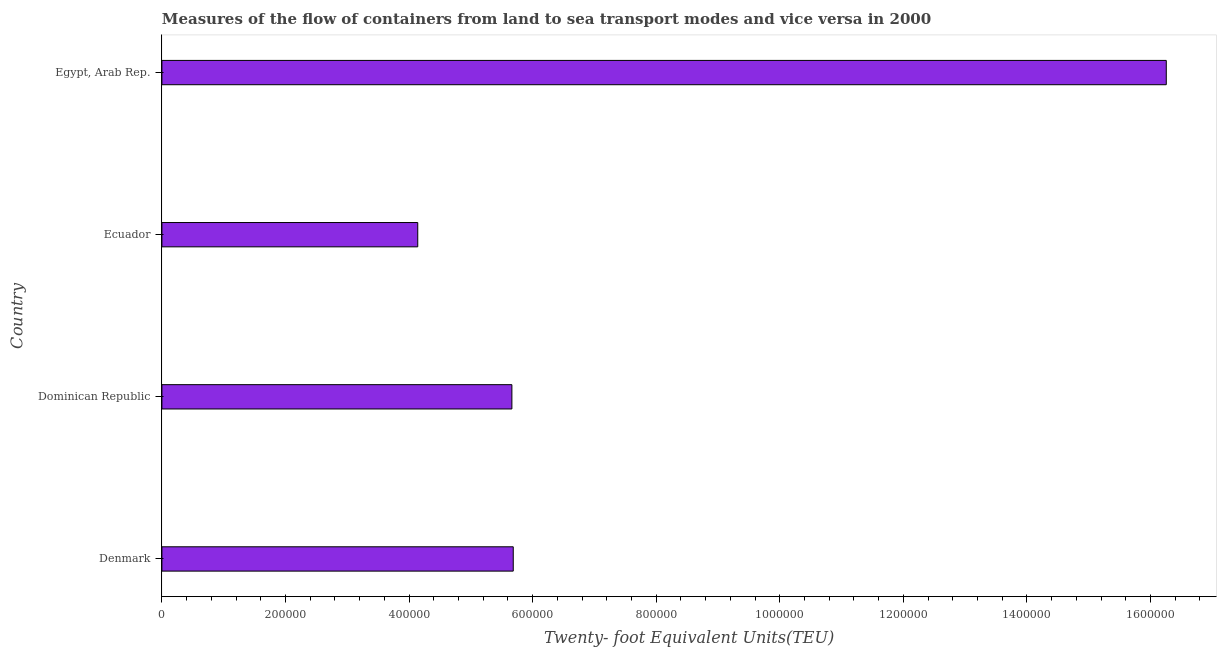Does the graph contain grids?
Make the answer very short. No. What is the title of the graph?
Provide a short and direct response. Measures of the flow of containers from land to sea transport modes and vice versa in 2000. What is the label or title of the X-axis?
Your response must be concise. Twenty- foot Equivalent Units(TEU). What is the container port traffic in Egypt, Arab Rep.?
Your answer should be compact. 1.63e+06. Across all countries, what is the maximum container port traffic?
Your response must be concise. 1.63e+06. Across all countries, what is the minimum container port traffic?
Ensure brevity in your answer.  4.14e+05. In which country was the container port traffic maximum?
Offer a very short reply. Egypt, Arab Rep. In which country was the container port traffic minimum?
Provide a short and direct response. Ecuador. What is the sum of the container port traffic?
Your answer should be compact. 3.17e+06. What is the difference between the container port traffic in Denmark and Egypt, Arab Rep.?
Ensure brevity in your answer.  -1.06e+06. What is the average container port traffic per country?
Your answer should be compact. 7.94e+05. What is the median container port traffic?
Your response must be concise. 5.68e+05. What is the ratio of the container port traffic in Denmark to that in Ecuador?
Make the answer very short. 1.37. What is the difference between the highest and the second highest container port traffic?
Give a very brief answer. 1.06e+06. What is the difference between the highest and the lowest container port traffic?
Offer a very short reply. 1.21e+06. In how many countries, is the container port traffic greater than the average container port traffic taken over all countries?
Offer a very short reply. 1. Are all the bars in the graph horizontal?
Keep it short and to the point. Yes. Are the values on the major ticks of X-axis written in scientific E-notation?
Your answer should be very brief. No. What is the Twenty- foot Equivalent Units(TEU) in Denmark?
Make the answer very short. 5.69e+05. What is the Twenty- foot Equivalent Units(TEU) in Dominican Republic?
Your answer should be very brief. 5.66e+05. What is the Twenty- foot Equivalent Units(TEU) of Ecuador?
Provide a short and direct response. 4.14e+05. What is the Twenty- foot Equivalent Units(TEU) in Egypt, Arab Rep.?
Offer a terse response. 1.63e+06. What is the difference between the Twenty- foot Equivalent Units(TEU) in Denmark and Dominican Republic?
Keep it short and to the point. 2181. What is the difference between the Twenty- foot Equivalent Units(TEU) in Denmark and Ecuador?
Offer a terse response. 1.55e+05. What is the difference between the Twenty- foot Equivalent Units(TEU) in Denmark and Egypt, Arab Rep.?
Your response must be concise. -1.06e+06. What is the difference between the Twenty- foot Equivalent Units(TEU) in Dominican Republic and Ecuador?
Keep it short and to the point. 1.52e+05. What is the difference between the Twenty- foot Equivalent Units(TEU) in Dominican Republic and Egypt, Arab Rep.?
Keep it short and to the point. -1.06e+06. What is the difference between the Twenty- foot Equivalent Units(TEU) in Ecuador and Egypt, Arab Rep.?
Ensure brevity in your answer.  -1.21e+06. What is the ratio of the Twenty- foot Equivalent Units(TEU) in Denmark to that in Dominican Republic?
Keep it short and to the point. 1. What is the ratio of the Twenty- foot Equivalent Units(TEU) in Denmark to that in Ecuador?
Give a very brief answer. 1.37. What is the ratio of the Twenty- foot Equivalent Units(TEU) in Dominican Republic to that in Ecuador?
Offer a terse response. 1.37. What is the ratio of the Twenty- foot Equivalent Units(TEU) in Dominican Republic to that in Egypt, Arab Rep.?
Offer a very short reply. 0.35. What is the ratio of the Twenty- foot Equivalent Units(TEU) in Ecuador to that in Egypt, Arab Rep.?
Offer a very short reply. 0.26. 